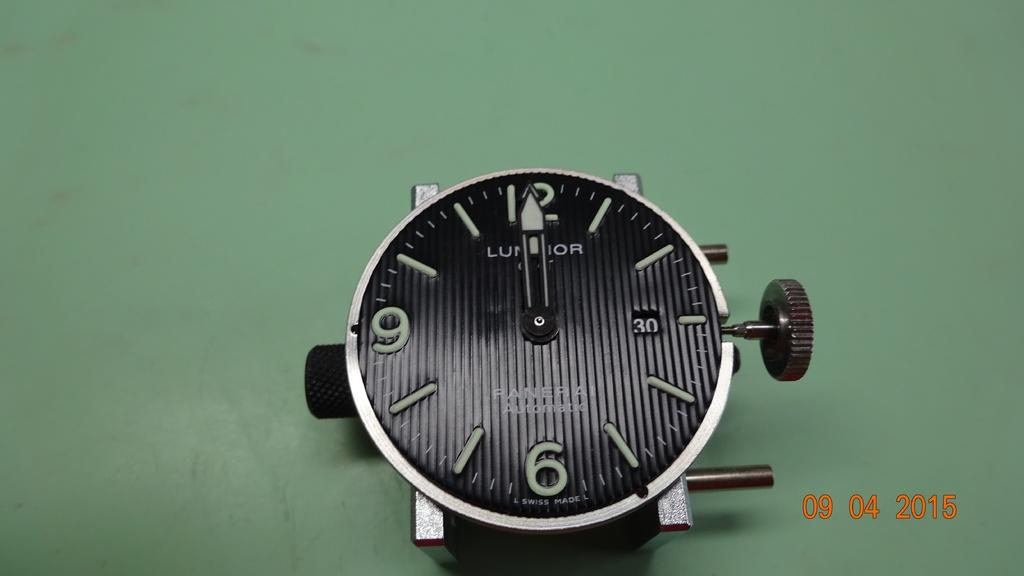What is the main object in the image? There is a clock's dial in the image. Where is the clock's dial located? The clock's dial is on a surface. What type of substance is being sung by the team in the image? There is no substance, song, or team present in the image; it only features a clock's dial on a surface. 